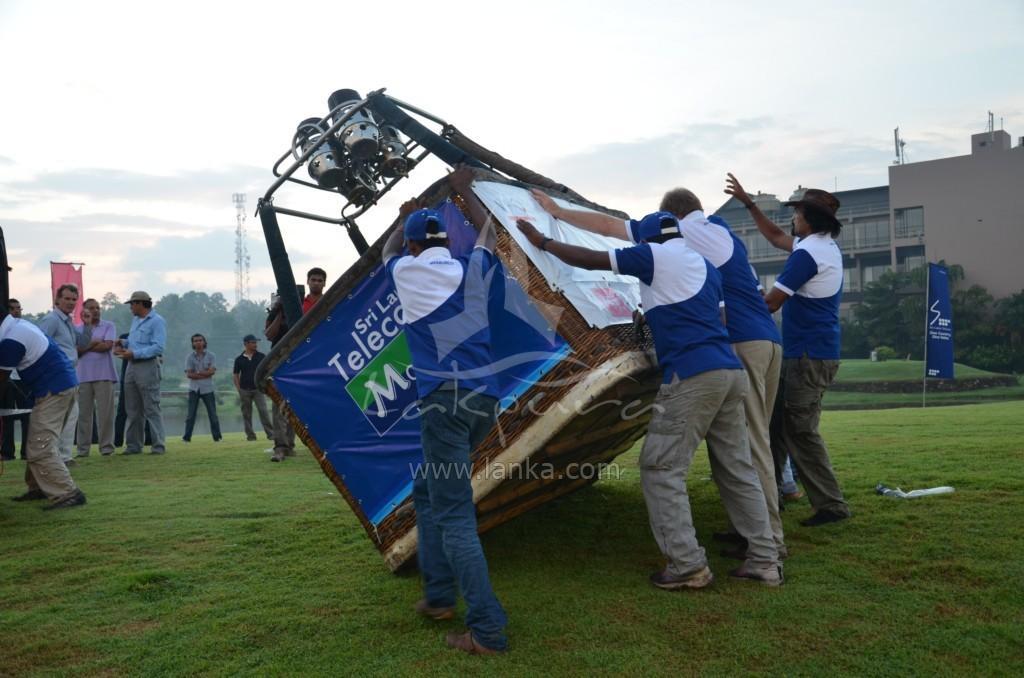Please provide a concise description of this image. In this image, we can see few people are holding a big basket. On the basket, we can see banners and few rods with objects are attached to the basket. Background we can see people, trees, buildings, walls, glass objects, banners, plants, banners and sky. At the bottom, we can see grass. In the middle of the image, there are few watermarks in the image. 